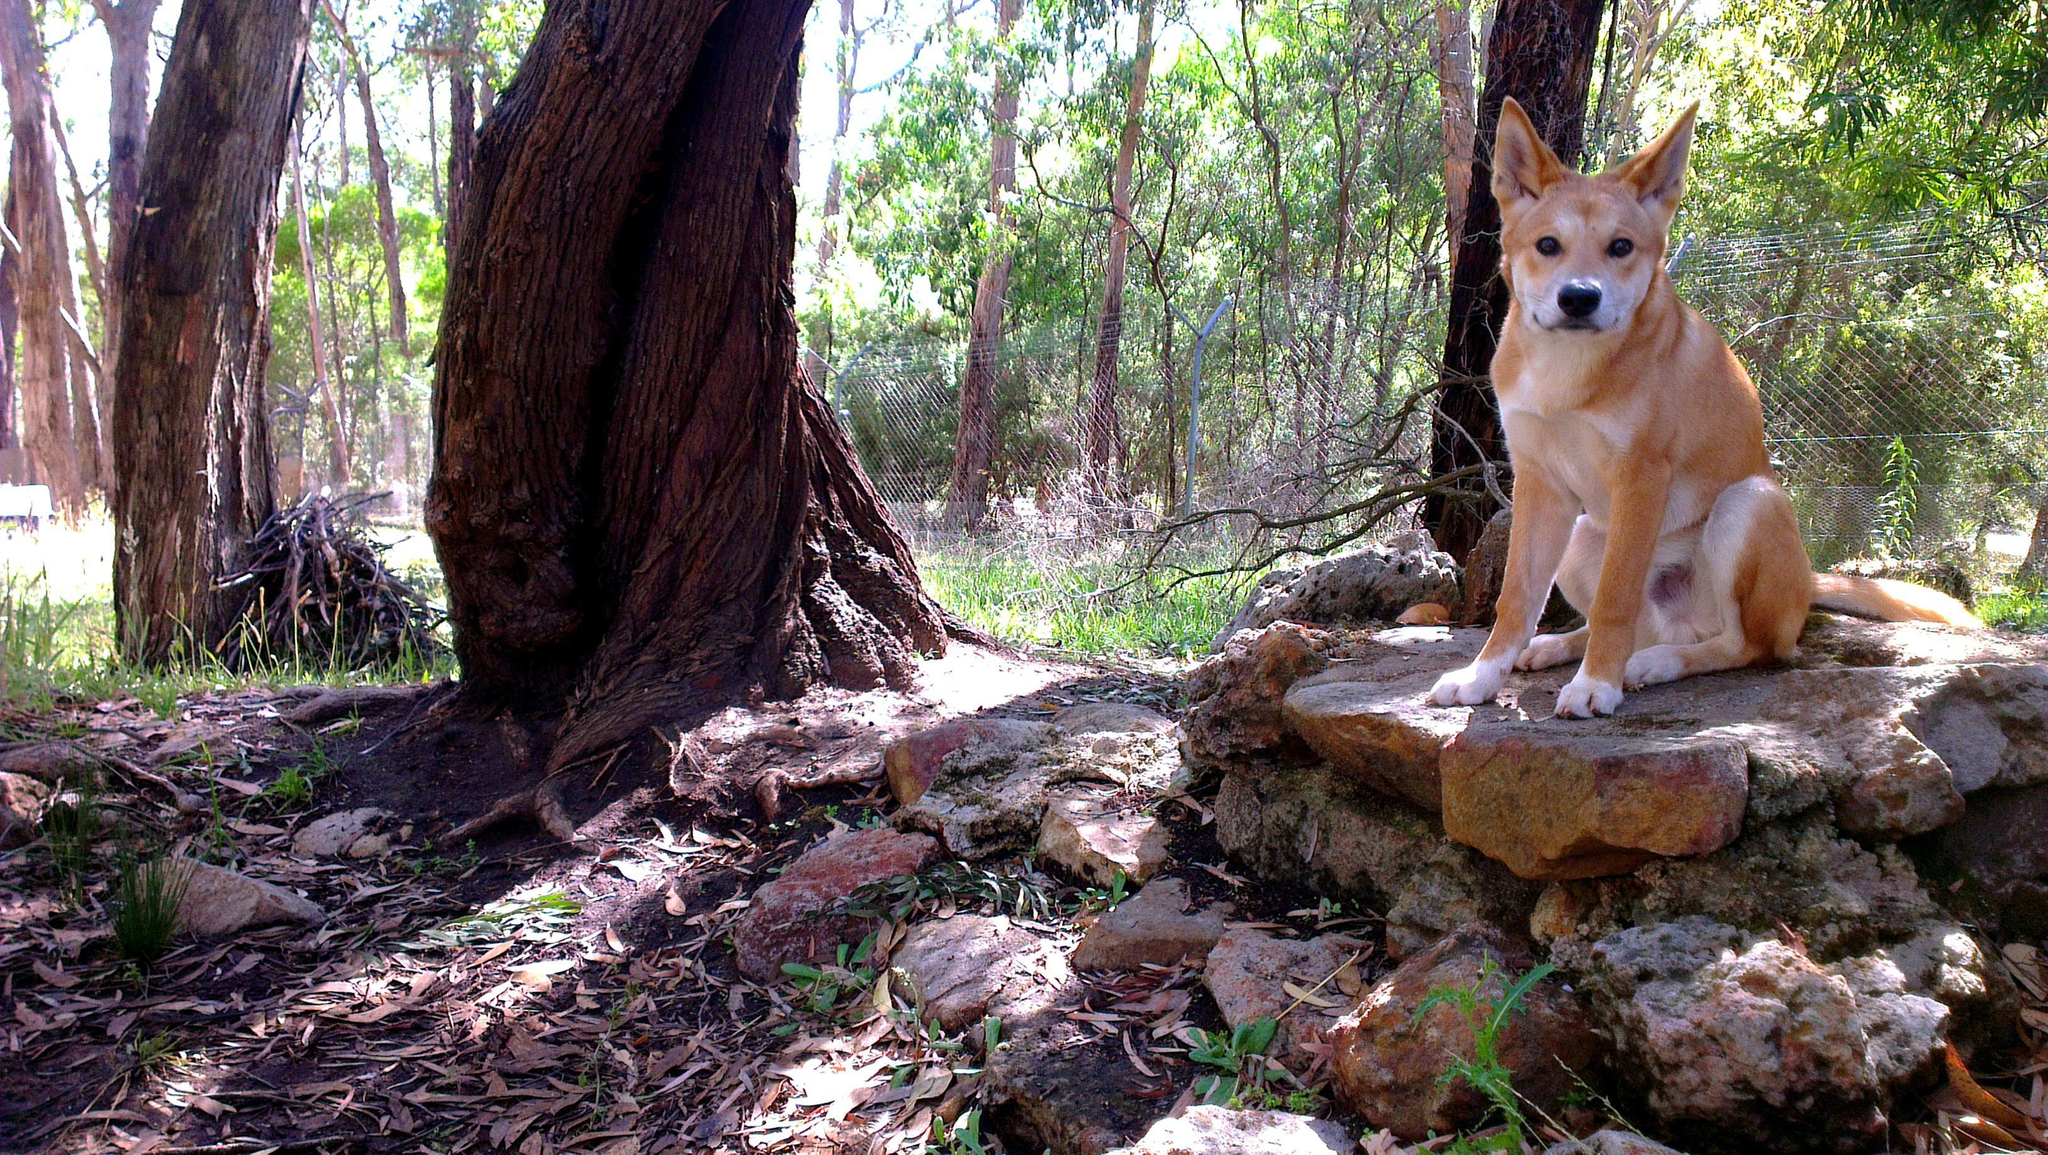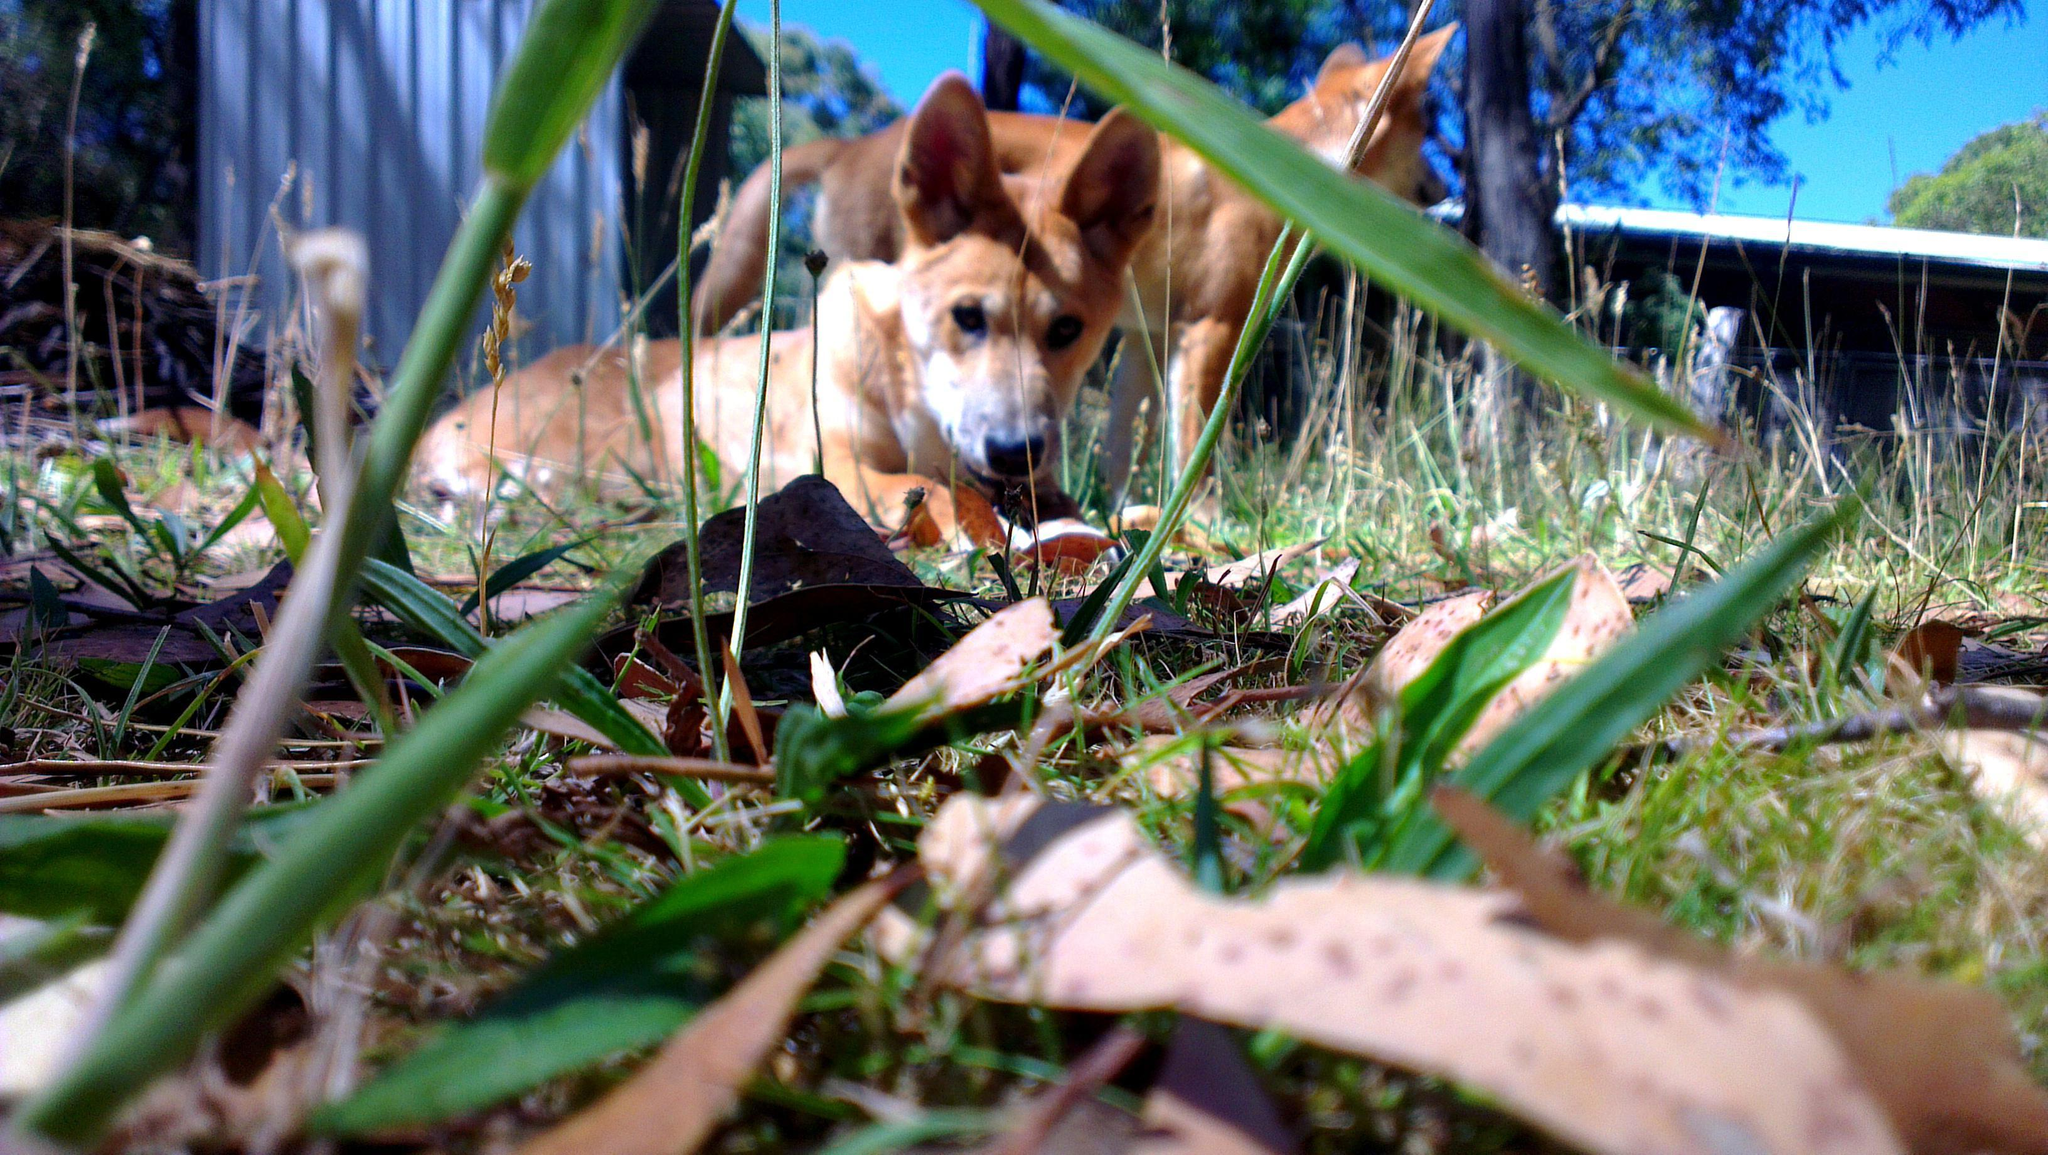The first image is the image on the left, the second image is the image on the right. Assess this claim about the two images: "A single dog is standing on the ground in the woods in the image on the left.". Correct or not? Answer yes or no. No. The first image is the image on the left, the second image is the image on the right. Analyze the images presented: Is the assertion "There are exactly three dogs in total." valid? Answer yes or no. Yes. 